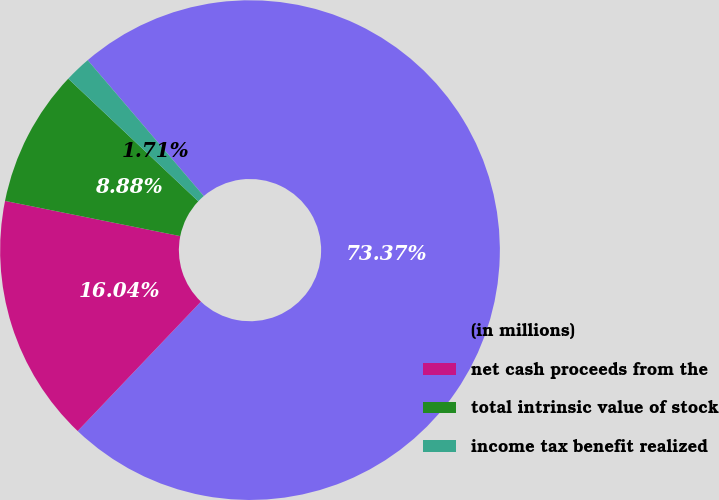<chart> <loc_0><loc_0><loc_500><loc_500><pie_chart><fcel>(in millions)<fcel>net cash proceeds from the<fcel>total intrinsic value of stock<fcel>income tax benefit realized<nl><fcel>73.36%<fcel>16.04%<fcel>8.88%<fcel>1.71%<nl></chart> 